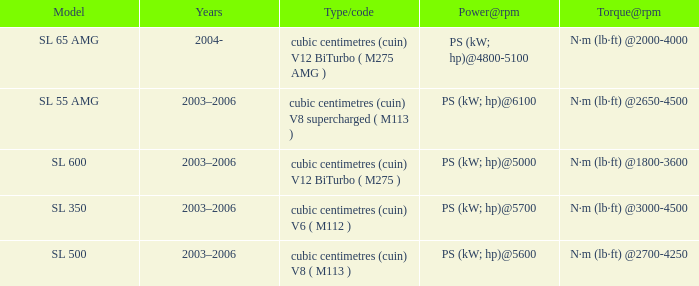What year was the SL 350 Model? 2003–2006. Could you parse the entire table as a dict? {'header': ['Model', 'Years', 'Type/code', 'Power@rpm', 'Torque@rpm'], 'rows': [['SL 65 AMG', '2004-', 'cubic centimetres (cuin) V12 BiTurbo ( M275 AMG )', 'PS (kW; hp)@4800-5100', 'N·m (lb·ft) @2000-4000'], ['SL 55 AMG', '2003–2006', 'cubic centimetres (cuin) V8 supercharged ( M113 )', 'PS (kW; hp)@6100', 'N·m (lb·ft) @2650-4500'], ['SL 600', '2003–2006', 'cubic centimetres (cuin) V12 BiTurbo ( M275 )', 'PS (kW; hp)@5000', 'N·m (lb·ft) @1800-3600'], ['SL 350', '2003–2006', 'cubic centimetres (cuin) V6 ( M112 )', 'PS (kW; hp)@5700', 'N·m (lb·ft) @3000-4500'], ['SL 500', '2003–2006', 'cubic centimetres (cuin) V8 ( M113 )', 'PS (kW; hp)@5600', 'N·m (lb·ft) @2700-4250']]} 